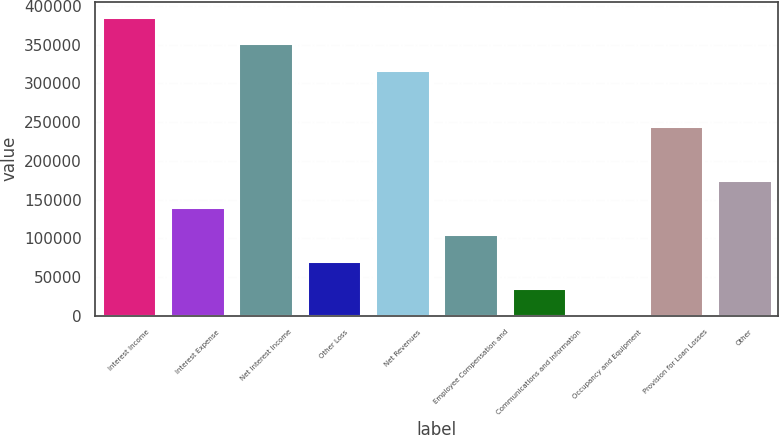<chart> <loc_0><loc_0><loc_500><loc_500><bar_chart><fcel>Interest Income<fcel>Interest Expense<fcel>Net Interest Income<fcel>Other Loss<fcel>Net Revenues<fcel>Employee Compensation and<fcel>Communications and Information<fcel>Occupancy and Equipment<fcel>Provision for Loan Losses<fcel>Other<nl><fcel>386280<fcel>140218<fcel>351464<fcel>70586.8<fcel>316649<fcel>105402<fcel>35771.4<fcel>956<fcel>244664<fcel>175033<nl></chart> 